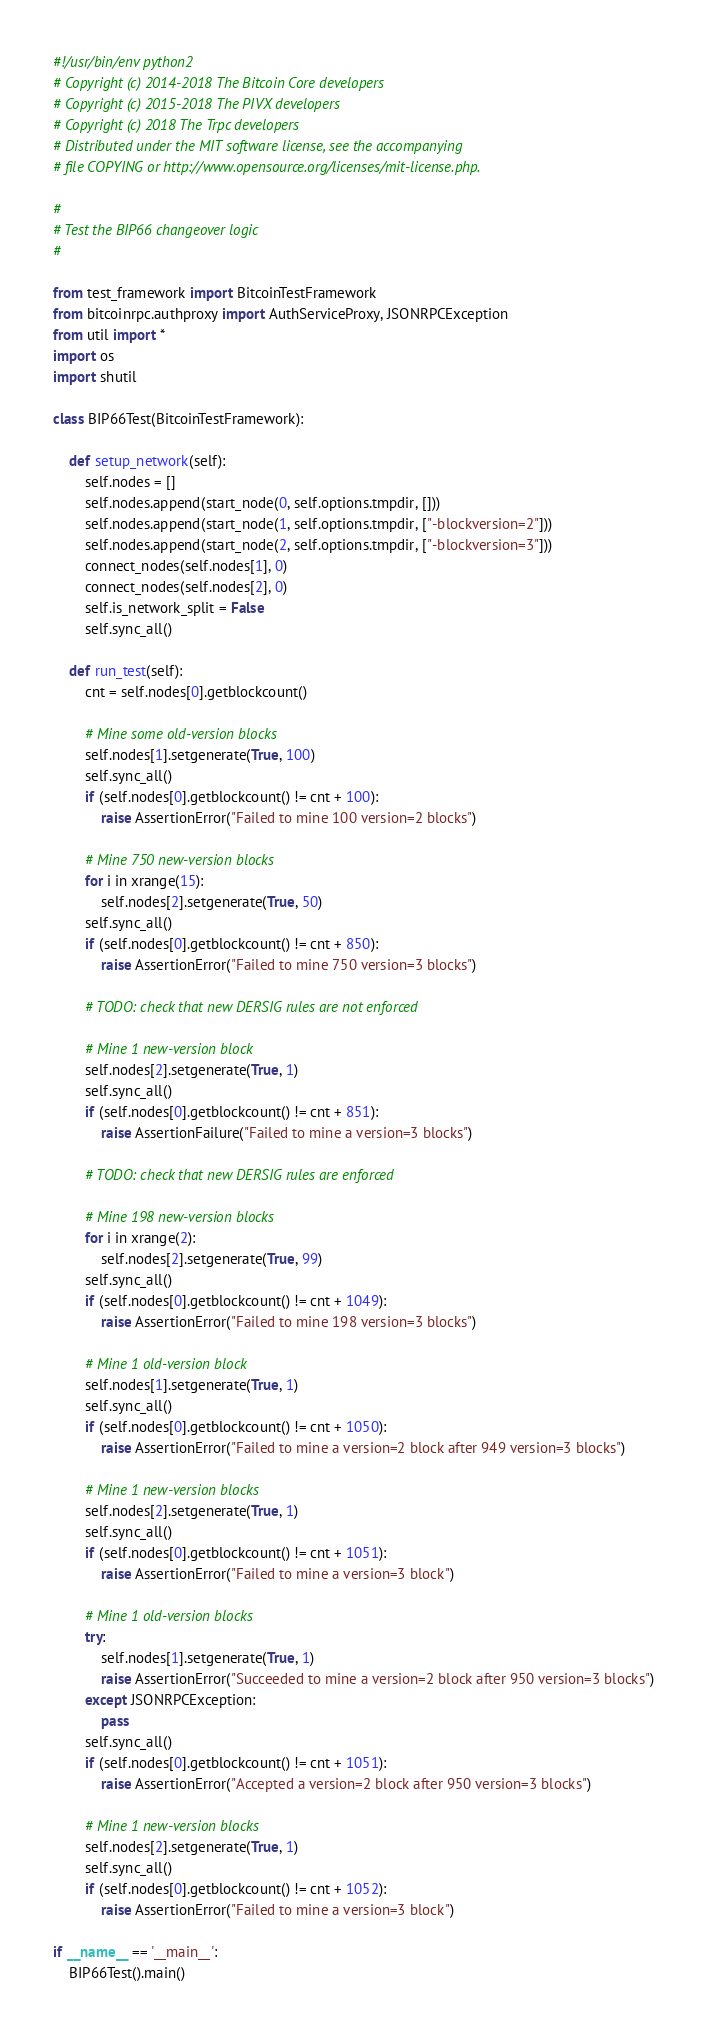Convert code to text. <code><loc_0><loc_0><loc_500><loc_500><_Python_>#!/usr/bin/env python2
# Copyright (c) 2014-2018 The Bitcoin Core developers
# Copyright (c) 2015-2018 The PIVX developers
# Copyright (c) 2018 The Trpc developers
# Distributed under the MIT software license, see the accompanying
# file COPYING or http://www.opensource.org/licenses/mit-license.php.

#
# Test the BIP66 changeover logic
#

from test_framework import BitcoinTestFramework
from bitcoinrpc.authproxy import AuthServiceProxy, JSONRPCException
from util import *
import os
import shutil

class BIP66Test(BitcoinTestFramework):

    def setup_network(self):
        self.nodes = []
        self.nodes.append(start_node(0, self.options.tmpdir, []))
        self.nodes.append(start_node(1, self.options.tmpdir, ["-blockversion=2"]))
        self.nodes.append(start_node(2, self.options.tmpdir, ["-blockversion=3"]))
        connect_nodes(self.nodes[1], 0)
        connect_nodes(self.nodes[2], 0)
        self.is_network_split = False
        self.sync_all()

    def run_test(self):
        cnt = self.nodes[0].getblockcount()

        # Mine some old-version blocks
        self.nodes[1].setgenerate(True, 100)
        self.sync_all()
        if (self.nodes[0].getblockcount() != cnt + 100):
            raise AssertionError("Failed to mine 100 version=2 blocks")

        # Mine 750 new-version blocks
        for i in xrange(15):
            self.nodes[2].setgenerate(True, 50)
        self.sync_all()
        if (self.nodes[0].getblockcount() != cnt + 850):
            raise AssertionError("Failed to mine 750 version=3 blocks")

        # TODO: check that new DERSIG rules are not enforced

        # Mine 1 new-version block
        self.nodes[2].setgenerate(True, 1)
        self.sync_all()
        if (self.nodes[0].getblockcount() != cnt + 851):
            raise AssertionFailure("Failed to mine a version=3 blocks")

        # TODO: check that new DERSIG rules are enforced

        # Mine 198 new-version blocks
        for i in xrange(2):
            self.nodes[2].setgenerate(True, 99)
        self.sync_all()
        if (self.nodes[0].getblockcount() != cnt + 1049):
            raise AssertionError("Failed to mine 198 version=3 blocks")

        # Mine 1 old-version block
        self.nodes[1].setgenerate(True, 1)
        self.sync_all()
        if (self.nodes[0].getblockcount() != cnt + 1050):
            raise AssertionError("Failed to mine a version=2 block after 949 version=3 blocks")

        # Mine 1 new-version blocks
        self.nodes[2].setgenerate(True, 1)
        self.sync_all()
        if (self.nodes[0].getblockcount() != cnt + 1051):
            raise AssertionError("Failed to mine a version=3 block")

        # Mine 1 old-version blocks
        try:
            self.nodes[1].setgenerate(True, 1)
            raise AssertionError("Succeeded to mine a version=2 block after 950 version=3 blocks")
        except JSONRPCException:
            pass
        self.sync_all()
        if (self.nodes[0].getblockcount() != cnt + 1051):
            raise AssertionError("Accepted a version=2 block after 950 version=3 blocks")

        # Mine 1 new-version blocks
        self.nodes[2].setgenerate(True, 1)
        self.sync_all()
        if (self.nodes[0].getblockcount() != cnt + 1052):
            raise AssertionError("Failed to mine a version=3 block")

if __name__ == '__main__':
    BIP66Test().main()
</code> 